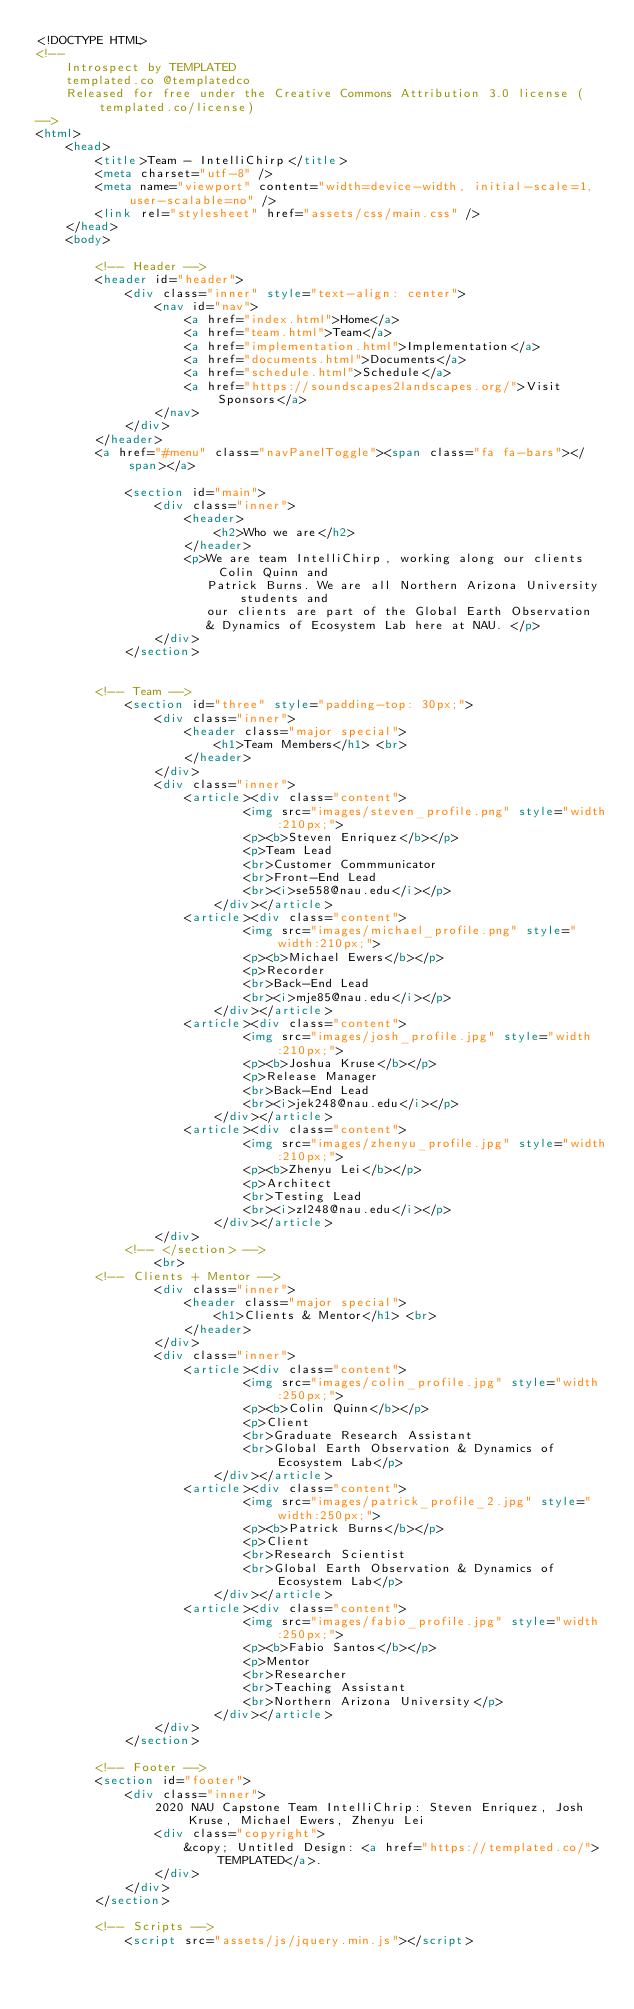Convert code to text. <code><loc_0><loc_0><loc_500><loc_500><_HTML_><!DOCTYPE HTML>
<!--
	Introspect by TEMPLATED
	templated.co @templatedco
	Released for free under the Creative Commons Attribution 3.0 license (templated.co/license)
-->
<html>
	<head>
		<title>Team - IntelliChirp</title>
		<meta charset="utf-8" />
		<meta name="viewport" content="width=device-width, initial-scale=1, user-scalable=no" />
		<link rel="stylesheet" href="assets/css/main.css" />
	</head>
	<body>

		<!-- Header -->
		<header id="header">
			<div class="inner" style="text-align: center">
				<nav id="nav">
					<a href="index.html">Home</a>
					<a href="team.html">Team</a>
					<a href="implementation.html">Implementation</a>
                    <a href="documents.html">Documents</a>
                    <a href="schedule.html">Schedule</a>
					<a href="https://soundscapes2landscapes.org/">Visit Sponsors</a>
				</nav>
			</div>
		</header>
		<a href="#menu" class="navPanelToggle"><span class="fa fa-bars"></span></a>

			<section id="main">
				<div class="inner">
					<header>
						<h2>Who we are</h2>
					</header>
					<p>We are team IntelliChirp, working along our clients Colin Quinn and 
                       Patrick Burns. We are all Northern Arizona University students and 
                       our clients are part of the Global Earth Observation 
                       & Dynamics of Ecosystem Lab here at NAU. </p>
				</div>
			</section>


        <!-- Team -->
            <section id="three" style="padding-top: 30px;">
                <div class="inner">
                    <header class="major special">
                        <h1>Team Members</h1> <br>
                    </header>
                </div>
                <div class="inner">
                    <article><div class="content">
                            <img src="images/steven_profile.png" style="width:210px;">
                            <p><b>Steven Enriquez</b></p>
                            <p>Team Lead
                            <br>Customer Commmunicator
                            <br>Front-End Lead
                            <br><i>se558@nau.edu</i></p>
                        </div></article>
                    <article><div class="content">
                            <img src="images/michael_profile.png" style="width:210px;">
                            <p><b>Michael Ewers</b></p>
                            <p>Recorder
                            <br>Back-End Lead
                            <br><i>mje85@nau.edu</i></p>
                        </div></article>
                    <article><div class="content">
                            <img src="images/josh_profile.jpg" style="width:210px;">
                            <p><b>Joshua Kruse</b></p>
                            <p>Release Manager
                            <br>Back-End Lead
                            <br><i>jek248@nau.edu</i></p>
                        </div></article>
                    <article><div class="content">
                            <img src="images/zhenyu_profile.jpg" style="width:210px;">
                            <p><b>Zhenyu Lei</b></p>
                            <p>Architect
                            <br>Testing Lead
                            <br><i>zl248@nau.edu</i></p>
                        </div></article>
                </div>
            <!-- </section> -->
                <br>
        <!-- Clients + Mentor -->
                <div class="inner">
                    <header class="major special">
                        <h1>Clients & Mentor</h1> <br>
                    </header>
                </div>
                <div class="inner">
                    <article><div class="content">
                            <img src="images/colin_profile.jpg" style="width:250px;">
                            <p><b>Colin Quinn</b></p>
                            <p>Client
                            <br>Graduate Research Assistant
                            <br>Global Earth Observation & Dynamics of Ecosystem Lab</p>
                        </div></article>
                    <article><div class="content">
                            <img src="images/patrick_profile_2.jpg" style="width:250px;">
                            <p><b>Patrick Burns</b></p>
                            <p>Client
                            <br>Research Scientist
                            <br>Global Earth Observation & Dynamics of Ecosystem Lab</p>
                        </div></article>
                    <article><div class="content">
                            <img src="images/fabio_profile.jpg" style="width:250px;">
                            <p><b>Fabio Santos</b></p>
                            <p>Mentor
                            <br>Researcher
                            <br>Teaching Assistant
                            <br>Northern Arizona University</p>
                        </div></article>
                </div>
            </section>

		<!-- Footer -->
        <section id="footer">
            <div class="inner">
                2020 NAU Capstone Team IntelliChrip: Steven Enriquez, Josh Kruse, Michael Ewers, Zhenyu Lei
                <div class="copyright">
                    &copy; Untitled Design: <a href="https://templated.co/">TEMPLATED</a>.
                </div>
            </div>
        </section>

		<!-- Scripts -->
			<script src="assets/js/jquery.min.js"></script></code> 